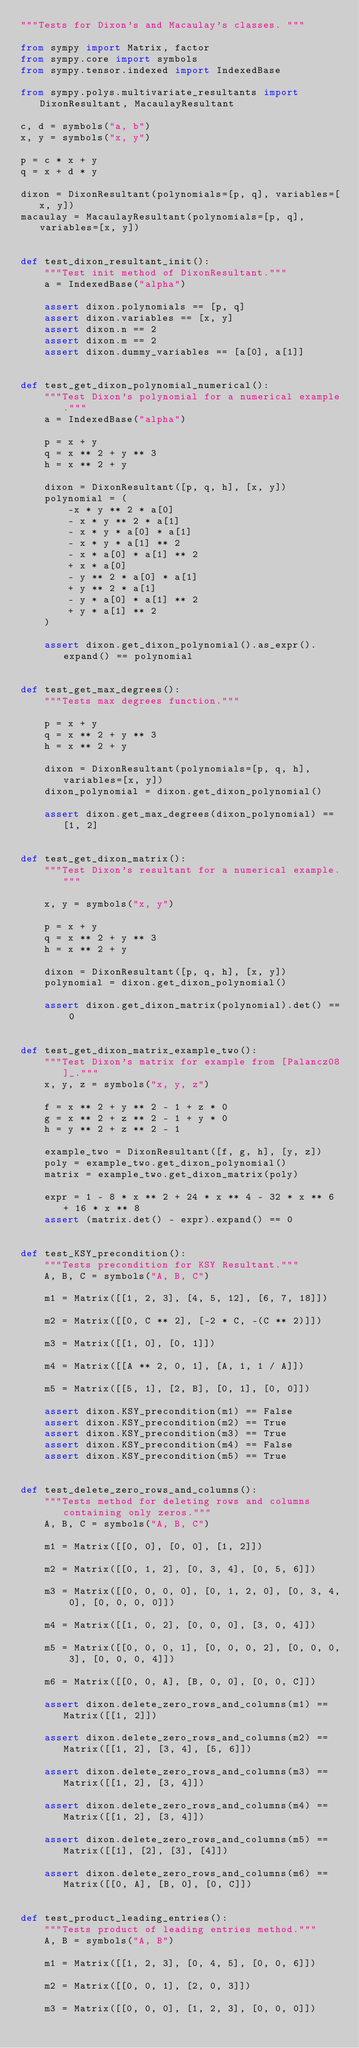Convert code to text. <code><loc_0><loc_0><loc_500><loc_500><_Python_>"""Tests for Dixon's and Macaulay's classes. """

from sympy import Matrix, factor
from sympy.core import symbols
from sympy.tensor.indexed import IndexedBase

from sympy.polys.multivariate_resultants import DixonResultant, MacaulayResultant

c, d = symbols("a, b")
x, y = symbols("x, y")

p = c * x + y
q = x + d * y

dixon = DixonResultant(polynomials=[p, q], variables=[x, y])
macaulay = MacaulayResultant(polynomials=[p, q], variables=[x, y])


def test_dixon_resultant_init():
    """Test init method of DixonResultant."""
    a = IndexedBase("alpha")

    assert dixon.polynomials == [p, q]
    assert dixon.variables == [x, y]
    assert dixon.n == 2
    assert dixon.m == 2
    assert dixon.dummy_variables == [a[0], a[1]]


def test_get_dixon_polynomial_numerical():
    """Test Dixon's polynomial for a numerical example."""
    a = IndexedBase("alpha")

    p = x + y
    q = x ** 2 + y ** 3
    h = x ** 2 + y

    dixon = DixonResultant([p, q, h], [x, y])
    polynomial = (
        -x * y ** 2 * a[0]
        - x * y ** 2 * a[1]
        - x * y * a[0] * a[1]
        - x * y * a[1] ** 2
        - x * a[0] * a[1] ** 2
        + x * a[0]
        - y ** 2 * a[0] * a[1]
        + y ** 2 * a[1]
        - y * a[0] * a[1] ** 2
        + y * a[1] ** 2
    )

    assert dixon.get_dixon_polynomial().as_expr().expand() == polynomial


def test_get_max_degrees():
    """Tests max degrees function."""

    p = x + y
    q = x ** 2 + y ** 3
    h = x ** 2 + y

    dixon = DixonResultant(polynomials=[p, q, h], variables=[x, y])
    dixon_polynomial = dixon.get_dixon_polynomial()

    assert dixon.get_max_degrees(dixon_polynomial) == [1, 2]


def test_get_dixon_matrix():
    """Test Dixon's resultant for a numerical example."""

    x, y = symbols("x, y")

    p = x + y
    q = x ** 2 + y ** 3
    h = x ** 2 + y

    dixon = DixonResultant([p, q, h], [x, y])
    polynomial = dixon.get_dixon_polynomial()

    assert dixon.get_dixon_matrix(polynomial).det() == 0


def test_get_dixon_matrix_example_two():
    """Test Dixon's matrix for example from [Palancz08]_."""
    x, y, z = symbols("x, y, z")

    f = x ** 2 + y ** 2 - 1 + z * 0
    g = x ** 2 + z ** 2 - 1 + y * 0
    h = y ** 2 + z ** 2 - 1

    example_two = DixonResultant([f, g, h], [y, z])
    poly = example_two.get_dixon_polynomial()
    matrix = example_two.get_dixon_matrix(poly)

    expr = 1 - 8 * x ** 2 + 24 * x ** 4 - 32 * x ** 6 + 16 * x ** 8
    assert (matrix.det() - expr).expand() == 0


def test_KSY_precondition():
    """Tests precondition for KSY Resultant."""
    A, B, C = symbols("A, B, C")

    m1 = Matrix([[1, 2, 3], [4, 5, 12], [6, 7, 18]])

    m2 = Matrix([[0, C ** 2], [-2 * C, -(C ** 2)]])

    m3 = Matrix([[1, 0], [0, 1]])

    m4 = Matrix([[A ** 2, 0, 1], [A, 1, 1 / A]])

    m5 = Matrix([[5, 1], [2, B], [0, 1], [0, 0]])

    assert dixon.KSY_precondition(m1) == False
    assert dixon.KSY_precondition(m2) == True
    assert dixon.KSY_precondition(m3) == True
    assert dixon.KSY_precondition(m4) == False
    assert dixon.KSY_precondition(m5) == True


def test_delete_zero_rows_and_columns():
    """Tests method for deleting rows and columns containing only zeros."""
    A, B, C = symbols("A, B, C")

    m1 = Matrix([[0, 0], [0, 0], [1, 2]])

    m2 = Matrix([[0, 1, 2], [0, 3, 4], [0, 5, 6]])

    m3 = Matrix([[0, 0, 0, 0], [0, 1, 2, 0], [0, 3, 4, 0], [0, 0, 0, 0]])

    m4 = Matrix([[1, 0, 2], [0, 0, 0], [3, 0, 4]])

    m5 = Matrix([[0, 0, 0, 1], [0, 0, 0, 2], [0, 0, 0, 3], [0, 0, 0, 4]])

    m6 = Matrix([[0, 0, A], [B, 0, 0], [0, 0, C]])

    assert dixon.delete_zero_rows_and_columns(m1) == Matrix([[1, 2]])

    assert dixon.delete_zero_rows_and_columns(m2) == Matrix([[1, 2], [3, 4], [5, 6]])

    assert dixon.delete_zero_rows_and_columns(m3) == Matrix([[1, 2], [3, 4]])

    assert dixon.delete_zero_rows_and_columns(m4) == Matrix([[1, 2], [3, 4]])

    assert dixon.delete_zero_rows_and_columns(m5) == Matrix([[1], [2], [3], [4]])

    assert dixon.delete_zero_rows_and_columns(m6) == Matrix([[0, A], [B, 0], [0, C]])


def test_product_leading_entries():
    """Tests product of leading entries method."""
    A, B = symbols("A, B")

    m1 = Matrix([[1, 2, 3], [0, 4, 5], [0, 0, 6]])

    m2 = Matrix([[0, 0, 1], [2, 0, 3]])

    m3 = Matrix([[0, 0, 0], [1, 2, 3], [0, 0, 0]])
</code> 